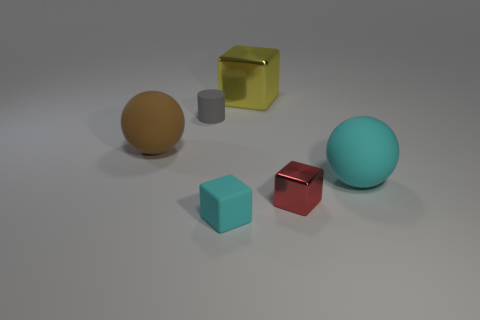Is the shape of the big cyan thing the same as the brown object?
Offer a terse response. Yes. There is a red thing that is the same shape as the large yellow metal thing; what is it made of?
Your response must be concise. Metal. What number of rubber objects have the same color as the matte block?
Provide a short and direct response. 1. There is a cyan ball that is the same material as the small gray thing; what is its size?
Offer a very short reply. Large. How many red objects are either small cylinders or big metallic blocks?
Ensure brevity in your answer.  0. What number of small red metallic blocks are to the left of the rubber ball that is right of the large metallic thing?
Your answer should be compact. 1. Is the number of blocks that are behind the cyan sphere greater than the number of small gray rubber cylinders behind the small gray thing?
Your response must be concise. Yes. What material is the small red thing?
Your answer should be compact. Metal. Is there a purple matte cylinder that has the same size as the brown matte object?
Keep it short and to the point. No. There is a gray cylinder that is the same size as the rubber cube; what is its material?
Provide a short and direct response. Rubber. 